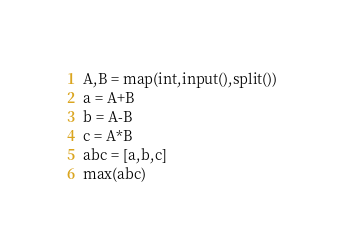Convert code to text. <code><loc_0><loc_0><loc_500><loc_500><_Python_>A,B = map(int,input(),split())
a = A+B
b = A-B
c = A*B
abc = [a,b,c]
max(abc)</code> 